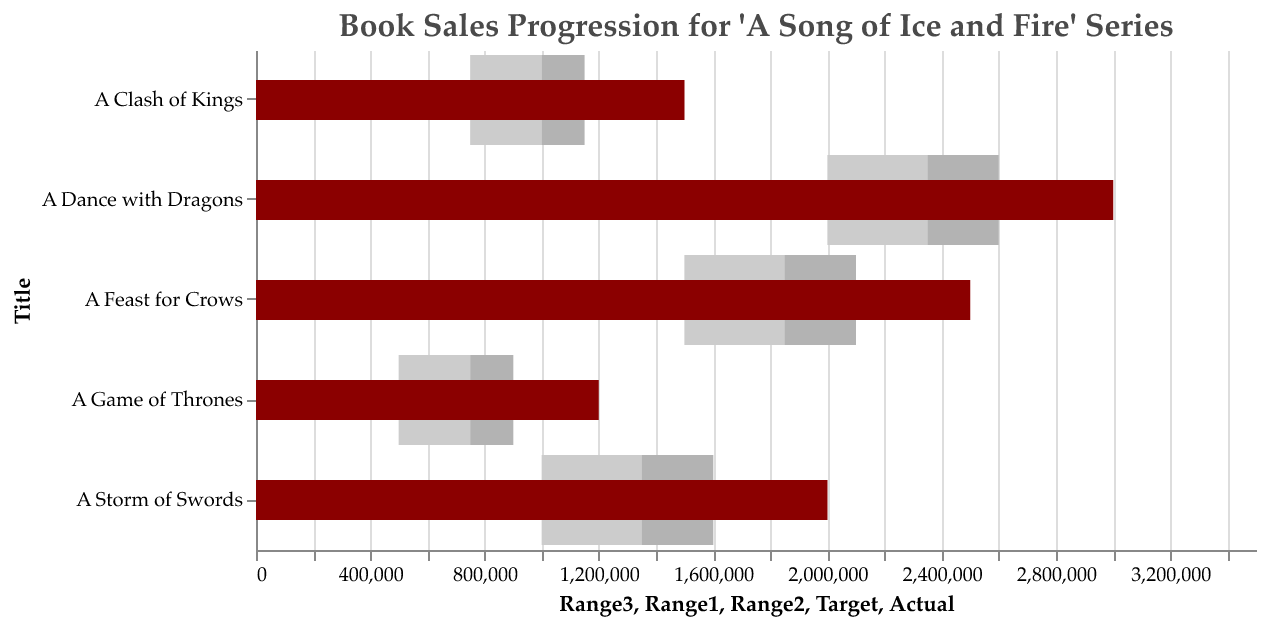What is the title of this chart? The title of the chart is usually placed at the top and is displayed prominently.
Answer: Book Sales Progression for 'A Song of Ice and Fire' Series Which book has the highest actual sales? The highest actual sales are represented by the tallest bar in dark color, which extends the furthest along the x-axis. Look for the longest bar in the dark color.
Answer: A Dance with Dragons What is the target sales figure for 'A Storm of Swords'? The target sales figure is represented by a line marker within the chart. Locate the line corresponding to 'A Storm of Swords' and see the value on the x-axis at that point.
Answer: 1,750,000 Compare the actual sales of 'A Clash of Kings' with its target sales. Find the bar corresponding to 'A Clash of Kings' and note its length along the x-axis for both the dark bar (actual sales) and the line marker (target sales).
Answer: Actual sales (1,500,000) are higher than target sales (1,250,000) Which book has the smallest difference between actual sales and target sales? Calculate the difference between the actual and target sales for each book. The book with the smallest difference will have the closest values for the dark bar and the line marker.
Answer: A Game of Thrones What color represents the actual sales in the chart? The actual sales are denoted by one uniform color in the provided bars.
Answer: Dark Red/Maroon What are the boundaries of the lightest color range for 'A Dance with Dragons'? The lightest color range (Range3) boundary can be observed by looking at the lightest bar segment for 'A Dance with Dragons'.
Answer: 2,000,000 to 2,600,000 How do the sales of 'A Game of Thrones' compare to its Range2? Look at the actual sales value for 'A Game of Thrones' and compare it with the lighter segment, Range2, which will be the range from the start of the bar to the start of the next color section.
Answer: It exceeds its Range2 (750,000 to 900,000) Which book's actual sales fall within its Range1? Range1 is the innermost range. Find the book where the dark bar (actual sales) aligns with the first colored section (Range1).
Answer: None Calculate the average of the target sales for all the books. Add the target sales of all books and divide by the number of books. That is (1000000 + 1250000 + 1750000 + 2250000 + 2750000) / 5.
Answer: 1,800,000 